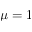Convert formula to latex. <formula><loc_0><loc_0><loc_500><loc_500>\mu = 1</formula> 